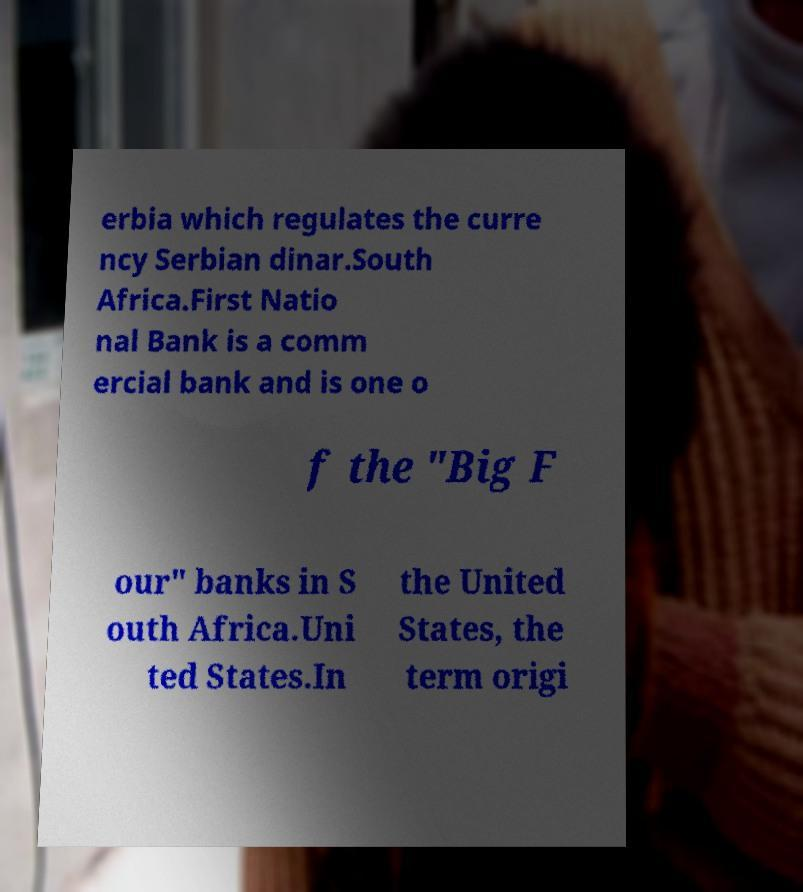Could you assist in decoding the text presented in this image and type it out clearly? erbia which regulates the curre ncy Serbian dinar.South Africa.First Natio nal Bank is a comm ercial bank and is one o f the "Big F our" banks in S outh Africa.Uni ted States.In the United States, the term origi 